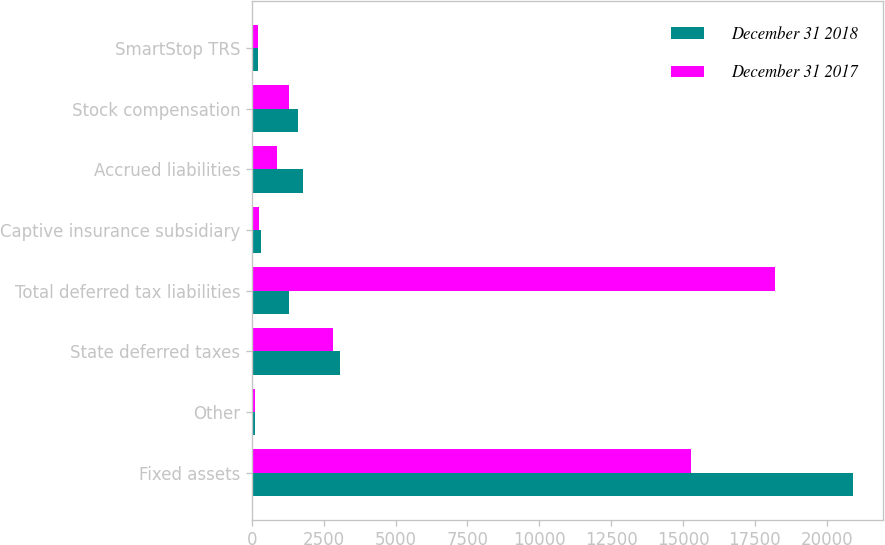<chart> <loc_0><loc_0><loc_500><loc_500><stacked_bar_chart><ecel><fcel>Fixed assets<fcel>Other<fcel>State deferred taxes<fcel>Total deferred tax liabilities<fcel>Captive insurance subsidiary<fcel>Accrued liabilities<fcel>Stock compensation<fcel>SmartStop TRS<nl><fcel>December 31 2018<fcel>20907<fcel>96<fcel>3076<fcel>1287<fcel>324<fcel>1772<fcel>1604<fcel>219<nl><fcel>December 31 2017<fcel>15271<fcel>108<fcel>2822<fcel>18201<fcel>252<fcel>873<fcel>1287<fcel>219<nl></chart> 